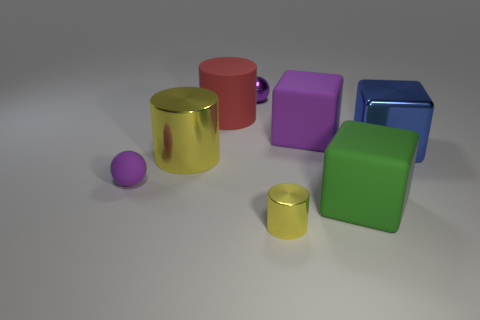Subtract all big shiny cylinders. How many cylinders are left? 2 Subtract all green cubes. How many cubes are left? 2 Subtract all cubes. How many objects are left? 5 Add 2 red rubber cylinders. How many objects exist? 10 Subtract all cyan cylinders. How many cyan balls are left? 0 Add 4 tiny purple things. How many tiny purple things are left? 6 Add 4 purple things. How many purple things exist? 7 Subtract 1 purple cubes. How many objects are left? 7 Subtract all brown cubes. Subtract all purple balls. How many cubes are left? 3 Subtract all small cyan objects. Subtract all big red things. How many objects are left? 7 